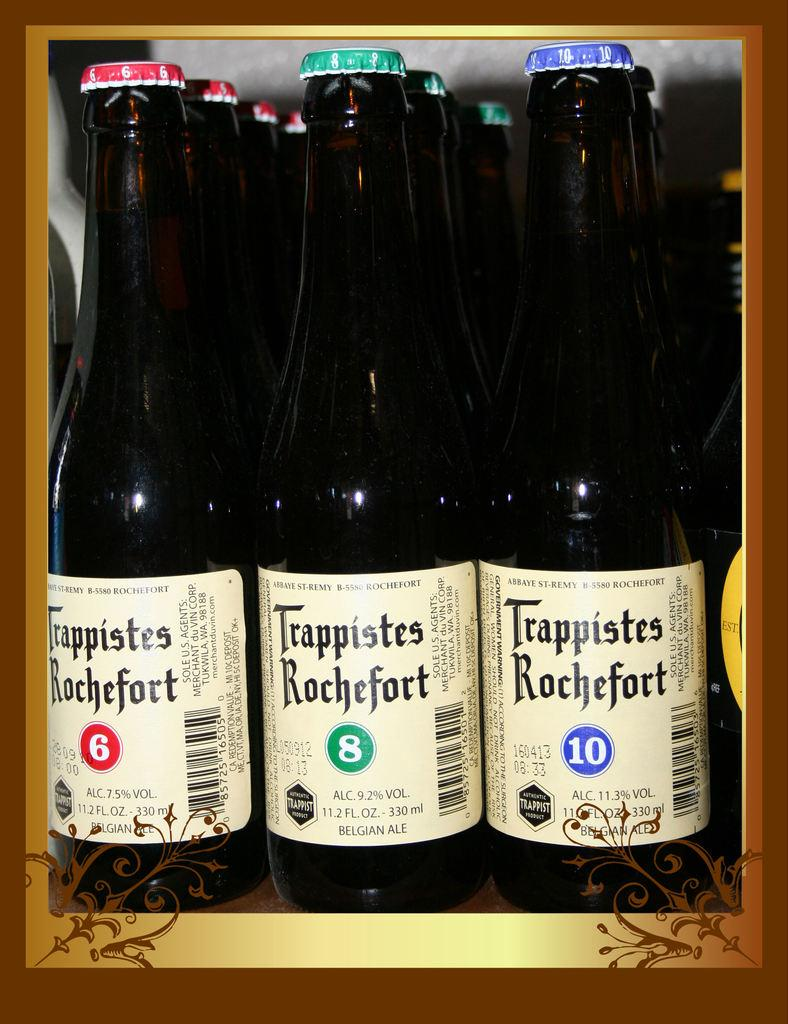<image>
Give a short and clear explanation of the subsequent image. Bottles of Belgian ales of different numbers, 6, 8, and 10 are displayed in rows. 